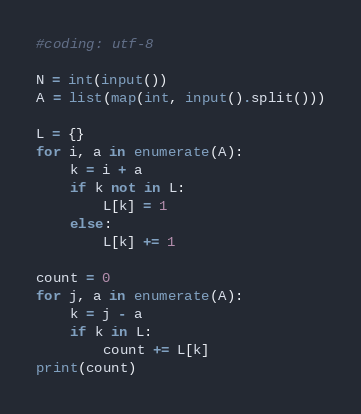Convert code to text. <code><loc_0><loc_0><loc_500><loc_500><_Python_>#coding: utf-8

N = int(input())
A = list(map(int, input().split()))

L = {}
for i, a in enumerate(A):
    k = i + a
    if k not in L:
        L[k] = 1
    else:
        L[k] += 1

count = 0
for j, a in enumerate(A):
    k = j - a
    if k in L:
        count += L[k]
print(count)
</code> 